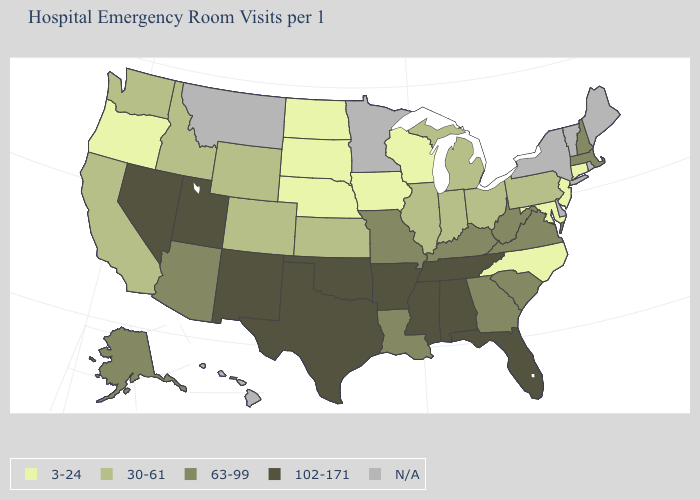What is the value of Missouri?
Answer briefly. 63-99. What is the value of West Virginia?
Short answer required. 63-99. What is the value of Hawaii?
Write a very short answer. N/A. Is the legend a continuous bar?
Write a very short answer. No. Which states hav the highest value in the Northeast?
Concise answer only. Massachusetts, New Hampshire. Does Oregon have the lowest value in the West?
Answer briefly. Yes. Name the states that have a value in the range 102-171?
Answer briefly. Alabama, Arkansas, Florida, Mississippi, Nevada, New Mexico, Oklahoma, Tennessee, Texas, Utah. Name the states that have a value in the range N/A?
Keep it brief. Delaware, Hawaii, Maine, Minnesota, Montana, New York, Rhode Island, Vermont. Does the map have missing data?
Write a very short answer. Yes. Name the states that have a value in the range 102-171?
Answer briefly. Alabama, Arkansas, Florida, Mississippi, Nevada, New Mexico, Oklahoma, Tennessee, Texas, Utah. Does South Dakota have the lowest value in the USA?
Short answer required. Yes. Name the states that have a value in the range 3-24?
Answer briefly. Connecticut, Iowa, Maryland, Nebraska, New Jersey, North Carolina, North Dakota, Oregon, South Dakota, Wisconsin. What is the value of Michigan?
Short answer required. 30-61. 